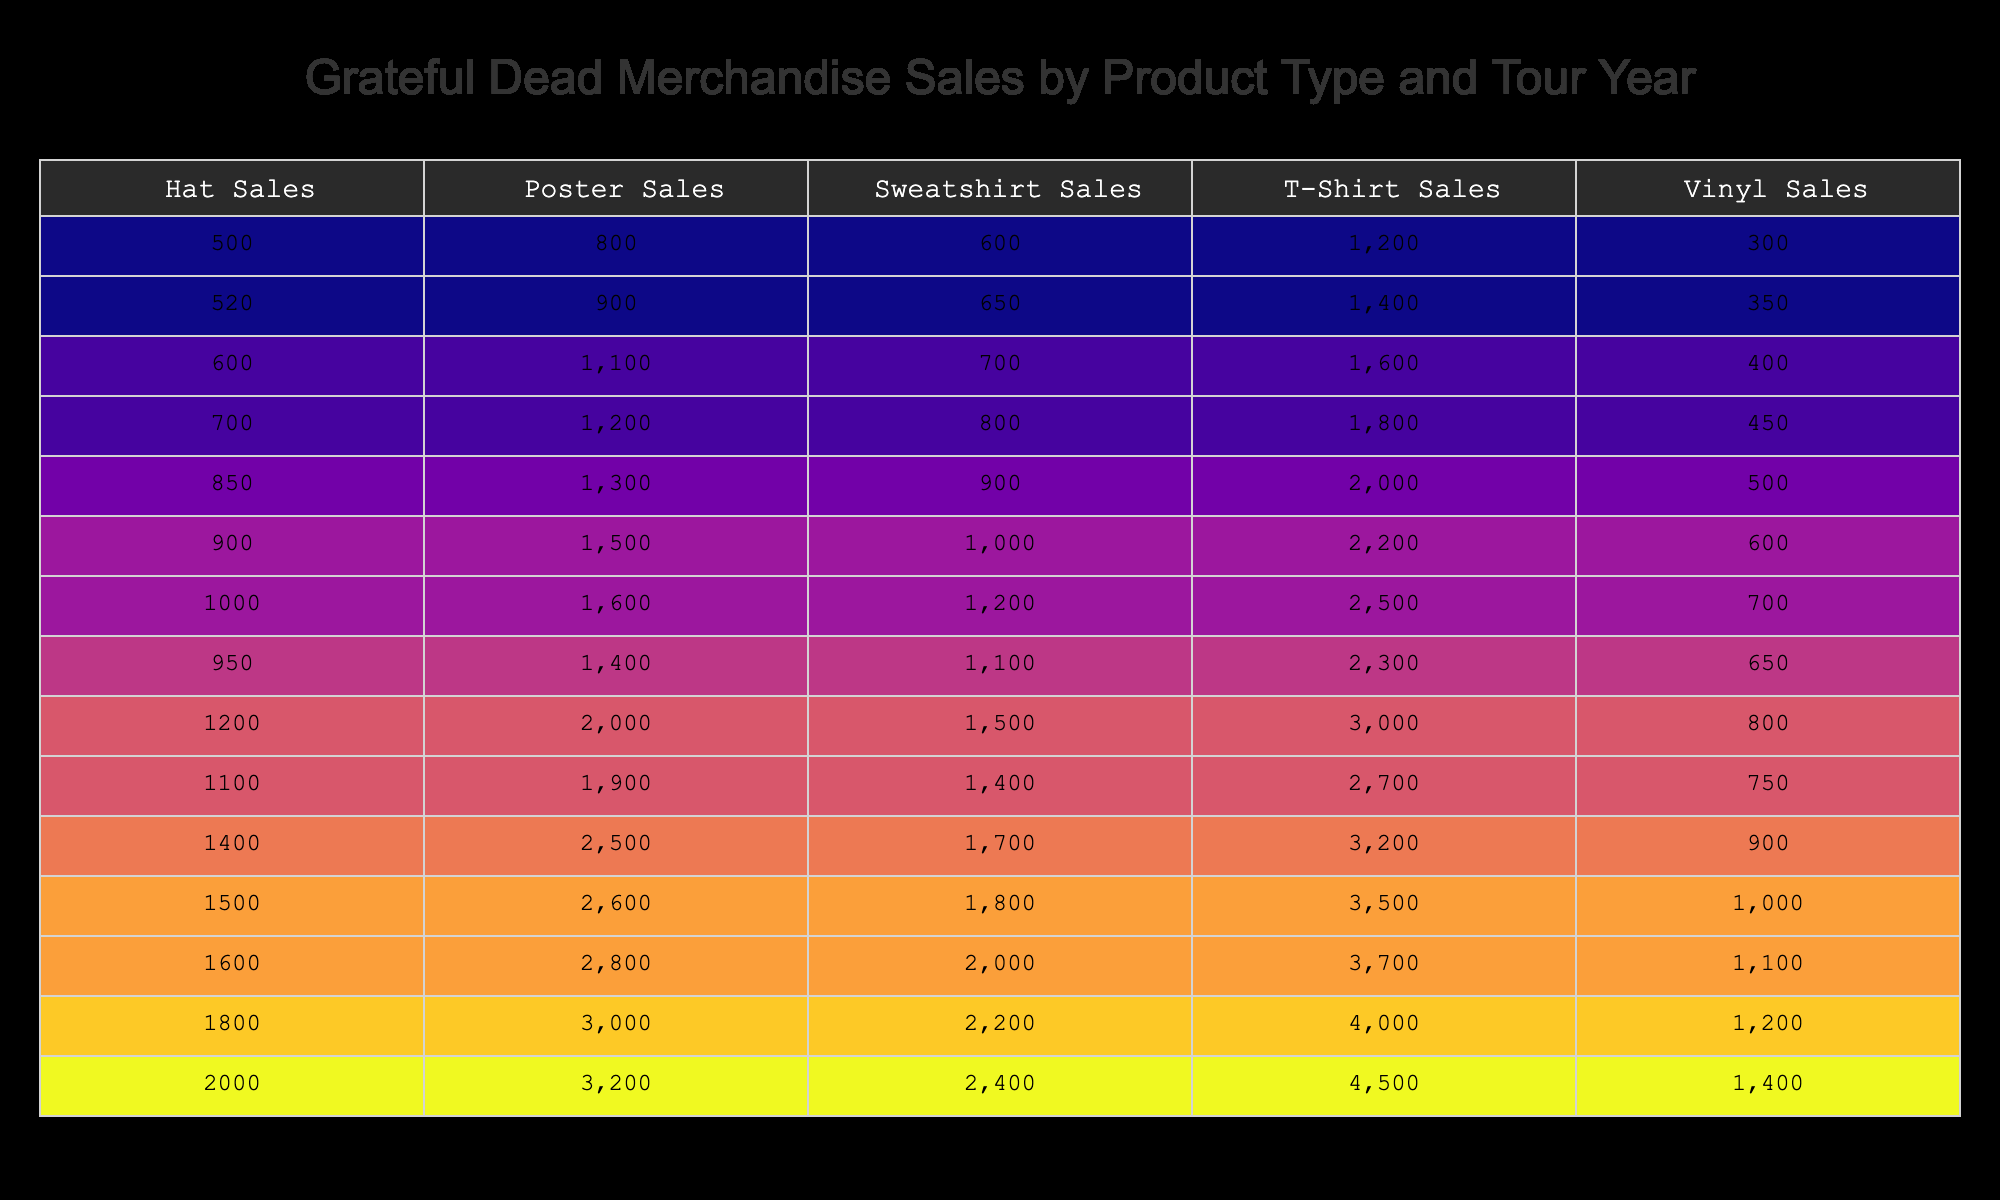What were the total T-Shirt Sales in 1972? To find the total T-Shirt Sales in 1972, I look for the row corresponding to that year in the T-Shirt Sales column, which is 2500.
Answer: 2500 Which year had the highest Hat Sales? I can see from the Hat Sales column that 1977 has the highest value at 1200.
Answer: 1977 Was there a year when Sweatshirt Sales exceeded 2000? By checking the Sweatshirt Sales column, no value exceeds 2000. The highest is 2400 in 2015, which does exceed 2000.
Answer: Yes What is the total revenue from Vinyl Sales from 1965 to 1975? I need to add the Vinyl Sales from each year: 300 (1965) + 350 (1966) + 400 (1967) + 450 (1968) + 500 (1970) + 600 (1971) + 700 (1972) + 650 (1974) = 3300.
Answer: 3300 In which year did Poster Sales first exceed 2500? I will look at the Poster Sales column: it first exceeds 2500 in 1990, where sales amount to 2500.
Answer: 1990 What is the average T-Shirt Sales from 1980 to 2015? The T-Shirt Sales from 1985 (2700), 1990 (3200), 1995 (3500), 2000 (3700), 2005 (4000), and 2015 (4500) are considered. Summing them gives 2700 + 3200 + 3500 + 3700 + 4000 + 4500 = 21600. Dividing this total by 6 (the number of years) gives an average of 3600.
Answer: 3600 Did Sweatshirt Sales decline at any point during the years listed? Checking the Sweatshirt Sales column shows no declines; each year’s sales increase sequentially from 600 in 1965 to 2400 in 2015.
Answer: No How many more Vinyl Sales did 1995 have compared to 1970? For 1995 Vinyl Sales, the value is 1000, and for 1970, it is 500. The difference is 1000 - 500 = 500.
Answer: 500 Which product type had the highest sales in 2005, and by how much was it higher than the lowest product type? In 2005, T-Shirt Sales were the highest at 4000, while Vinyl Sales were the lowest at 1200. The difference is 4000 - 1200 = 2800.
Answer: T-Shirt Sales; 2800 